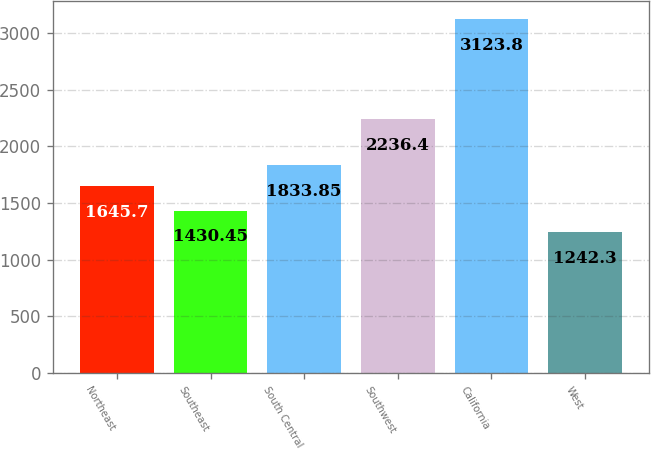Convert chart. <chart><loc_0><loc_0><loc_500><loc_500><bar_chart><fcel>Northeast<fcel>Southeast<fcel>South Central<fcel>Southwest<fcel>California<fcel>West<nl><fcel>1645.7<fcel>1430.45<fcel>1833.85<fcel>2236.4<fcel>3123.8<fcel>1242.3<nl></chart> 